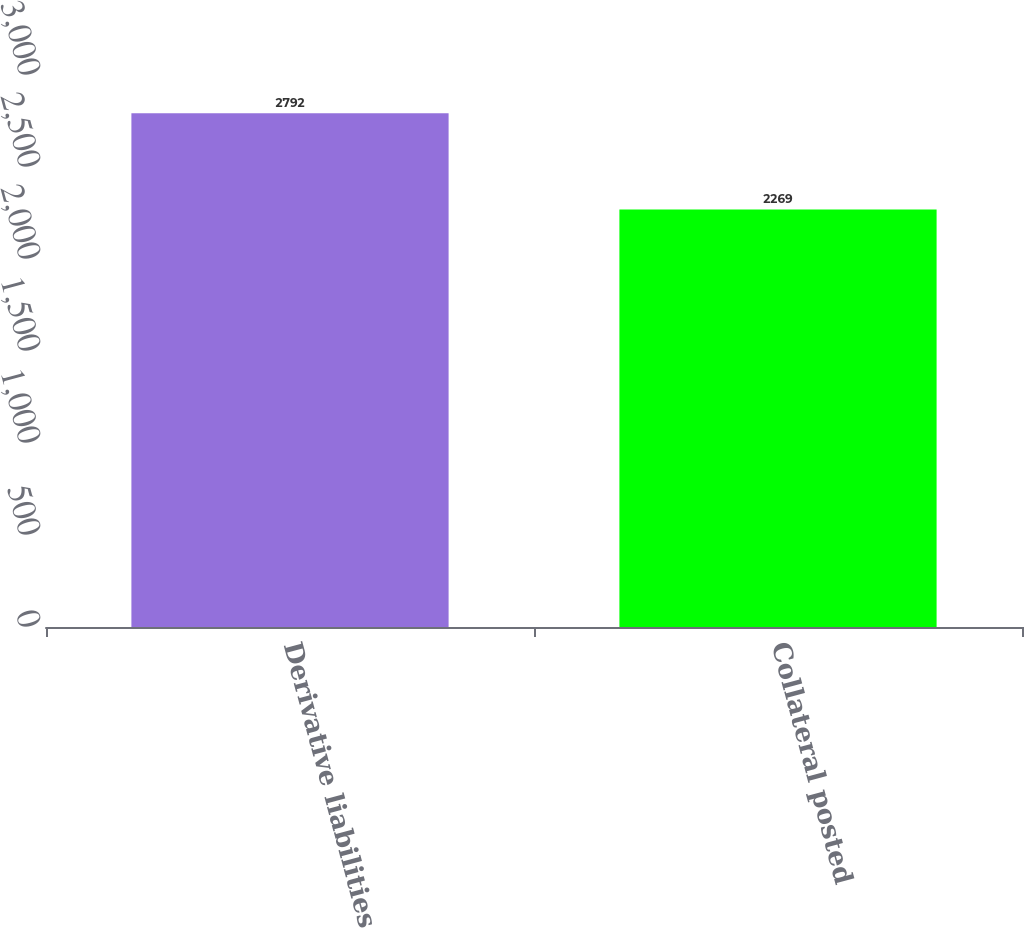Convert chart to OTSL. <chart><loc_0><loc_0><loc_500><loc_500><bar_chart><fcel>Derivative liabilities<fcel>Collateral posted<nl><fcel>2792<fcel>2269<nl></chart> 